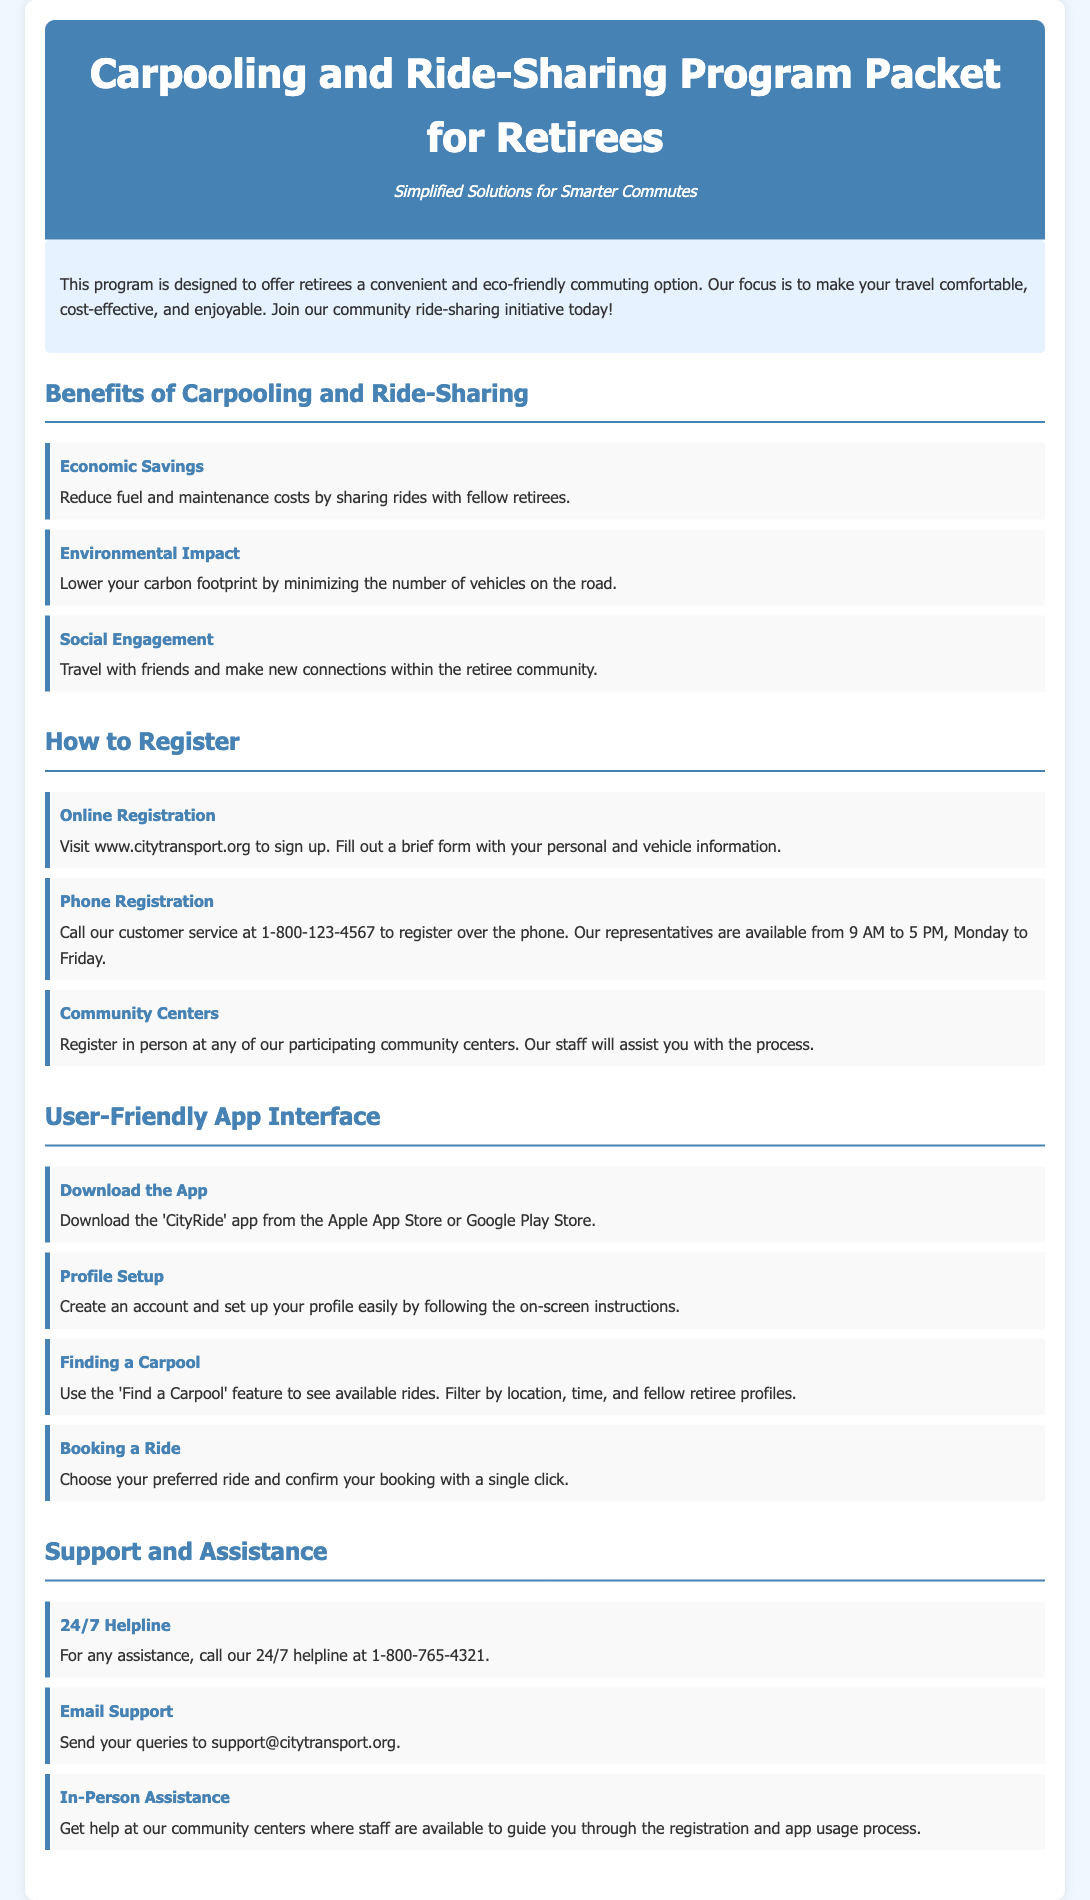What are the economic benefits of carpooling? Economic benefits include reduction in fuel and maintenance costs by sharing rides with fellow retirees.
Answer: Reduction in fuel and maintenance costs What is the website for online registration? The document mentions that online registration can be done at the given website.
Answer: www.citytransport.org What is the contact number for phone registration? The document provides a specific phone number for registering over the phone.
Answer: 1-800-123-4567 What app should retirees download for the program? The document specifies the name of the app available for download.
Answer: CityRide What feature helps to find available rides? The feature that assists users in locating available rides is mentioned in the document.
Answer: Find a Carpool What is the email support address? The document includes a designated email address for support inquiries.
Answer: support@citytransport.org How many hours is the helpline available? The document states the availability of the helpline for assistance.
Answer: 24/7 What type of centers assist with registration? The document lists locations where retirees can register in person.
Answer: Community centers 